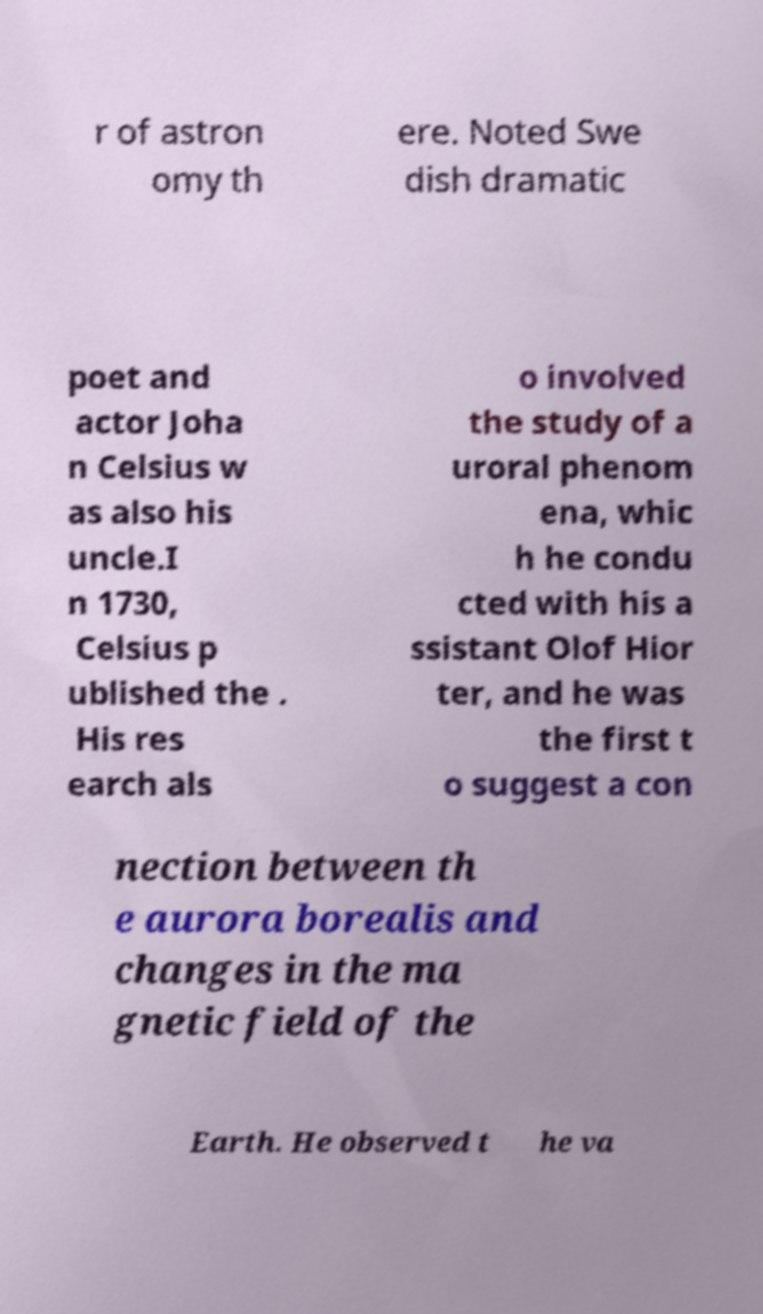Could you extract and type out the text from this image? r of astron omy th ere. Noted Swe dish dramatic poet and actor Joha n Celsius w as also his uncle.I n 1730, Celsius p ublished the . His res earch als o involved the study of a uroral phenom ena, whic h he condu cted with his a ssistant Olof Hior ter, and he was the first t o suggest a con nection between th e aurora borealis and changes in the ma gnetic field of the Earth. He observed t he va 